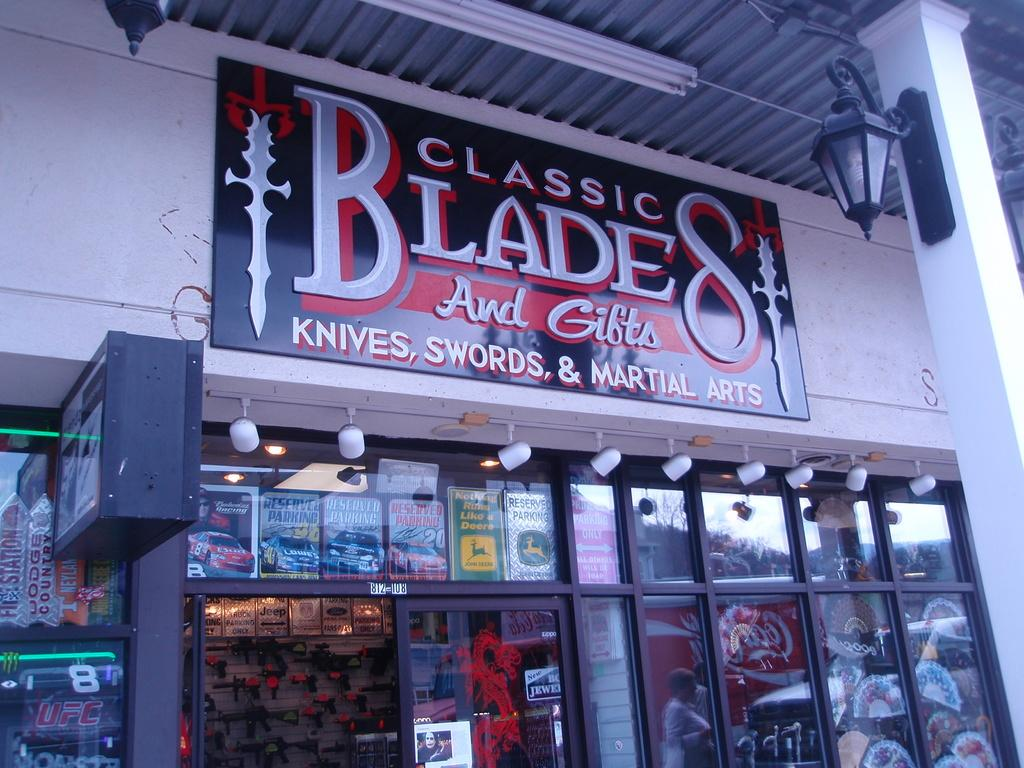<image>
Share a concise interpretation of the image provided. Classic Blades and Gifts sells knives, swords, and martial arts weapons. 